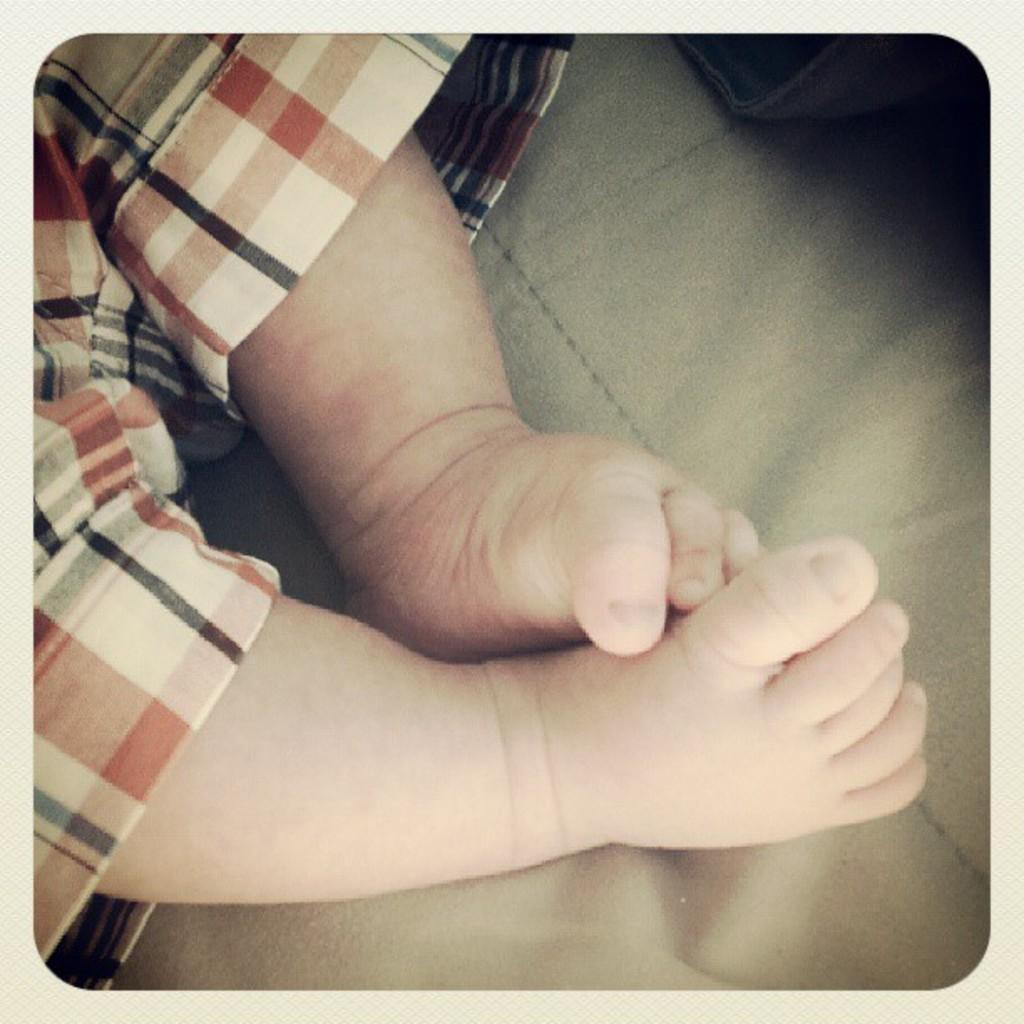Who or what is present in the image? There is a person in the image. What is the color of the object in the image? The object in the image is black in color. What is the color of the surface on which the object is placed? The surface is brown in color. How does the person slip on the board in the image? There is no board present in the image, and the person is not shown slipping. 